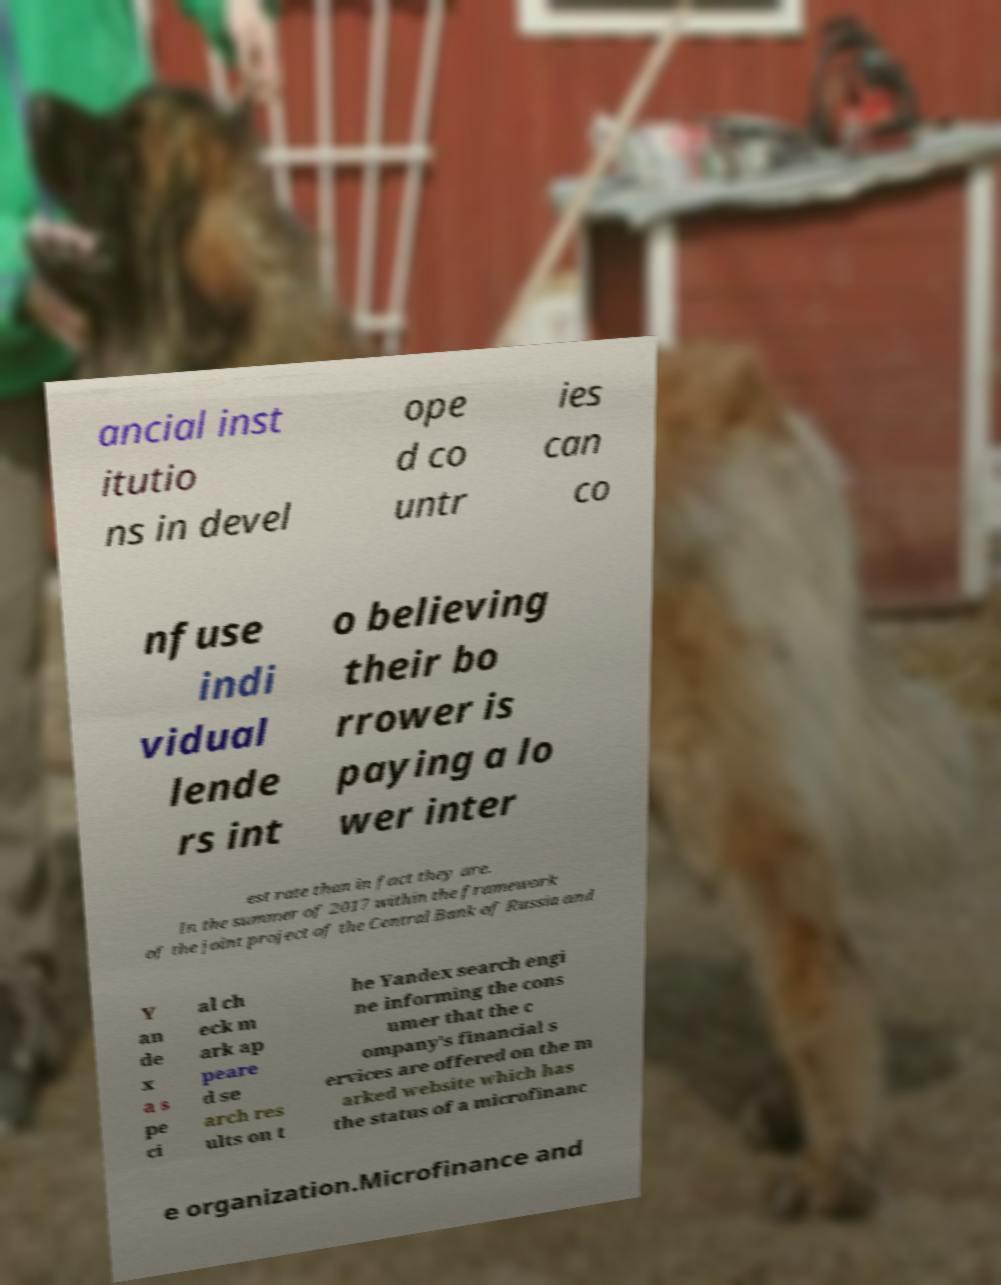There's text embedded in this image that I need extracted. Can you transcribe it verbatim? ancial inst itutio ns in devel ope d co untr ies can co nfuse indi vidual lende rs int o believing their bo rrower is paying a lo wer inter est rate than in fact they are. In the summer of 2017 within the framework of the joint project of the Central Bank of Russia and Y an de x a s pe ci al ch eck m ark ap peare d se arch res ults on t he Yandex search engi ne informing the cons umer that the c ompany's financial s ervices are offered on the m arked website which has the status of a microfinanc e organization.Microfinance and 